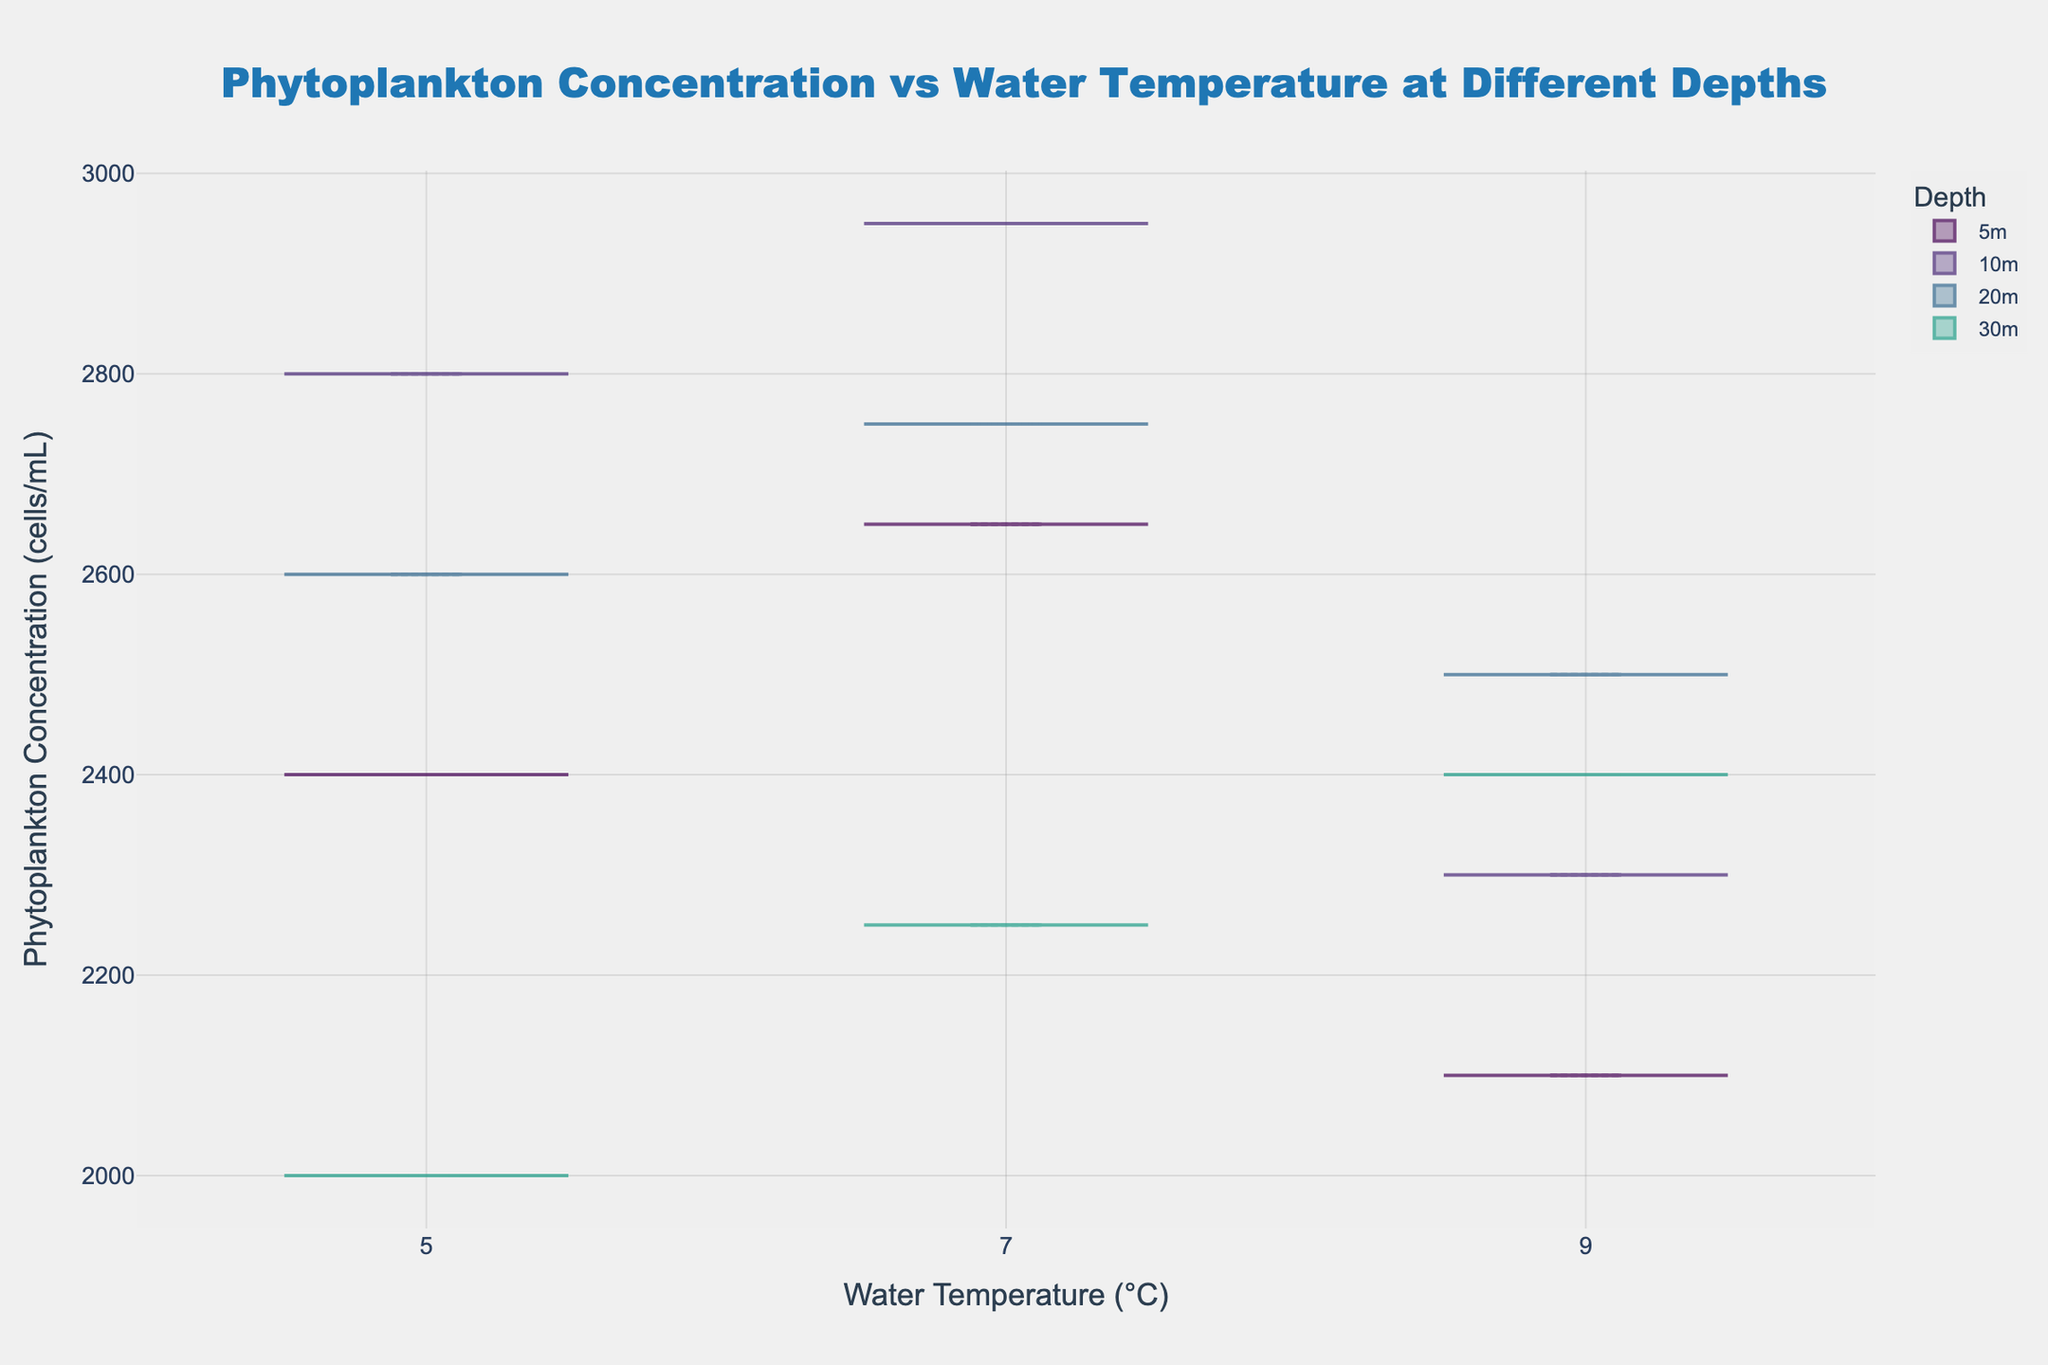What is the title of the plot? The title of the plot is located at the top and is visually distinguished with a larger font size and a particular font style. From the given data, it reads: 'Phytoplankton Concentration vs Water Temperature at Different Depths'.
Answer: Phytoplankton Concentration vs Water Temperature at Different Depths What is the x-axis title? The x-axis title is displayed horizontally below the x-axis and typically provides information about the variable measured on the x-axis. It reads: 'Water Temperature (°C)'.
Answer: Water Temperature (°C) Which depth has the highest median phytoplankton concentration at 7°C? To determine this, look for the black line inside the box (the median) for each depth at 7°C. Identify the highest median value among the depths.
Answer: 10m How does the variability of phytoplankton concentration change with depth at 5°C? Compare the spread of the data points within the violin plot for each depth at 5°C. A wider spread indicates higher variability.
Answer: The variability decreases with depth, highest at 10m At 9°C, which depth shows the least variation in phytoplankton concentration? The least variation is indicated by the narrowest width of the violin plot at 9°C. Examine all depths and choose the one with the least spread.
Answer: 5m What is the average phytoplankton concentration at 20m across all temperatures? Calculate the mean of phytoplankton concentrations at 20m for all temperatures (2600 + 2750 + 2500)/3.
Answer: 2617 cells/mL Between 5m and 30m, which depth has a lower range of phytoplankton concentration at 9°C? Compare the range (difference between maximum and minimum values) of the phytoplankton concentration at 9°C for both 5m and 30m depths by examining the length of the violin plot vertically.
Answer: 30m At which depth does the mean phytoplankton concentration decrease as water temperature increases from 5°C to 9°C? Look for depths where the mean line in the violin plots decreases in value as the temperature increases from 5°C to 9°C.
Answer: 5m Which depth has the highest phytoplankton concentration variability at 7°C? Assess the width of the violin plots at 7°C for all depths and identify the depth with the widest plot, as it indicates the highest variability.
Answer: 10m 